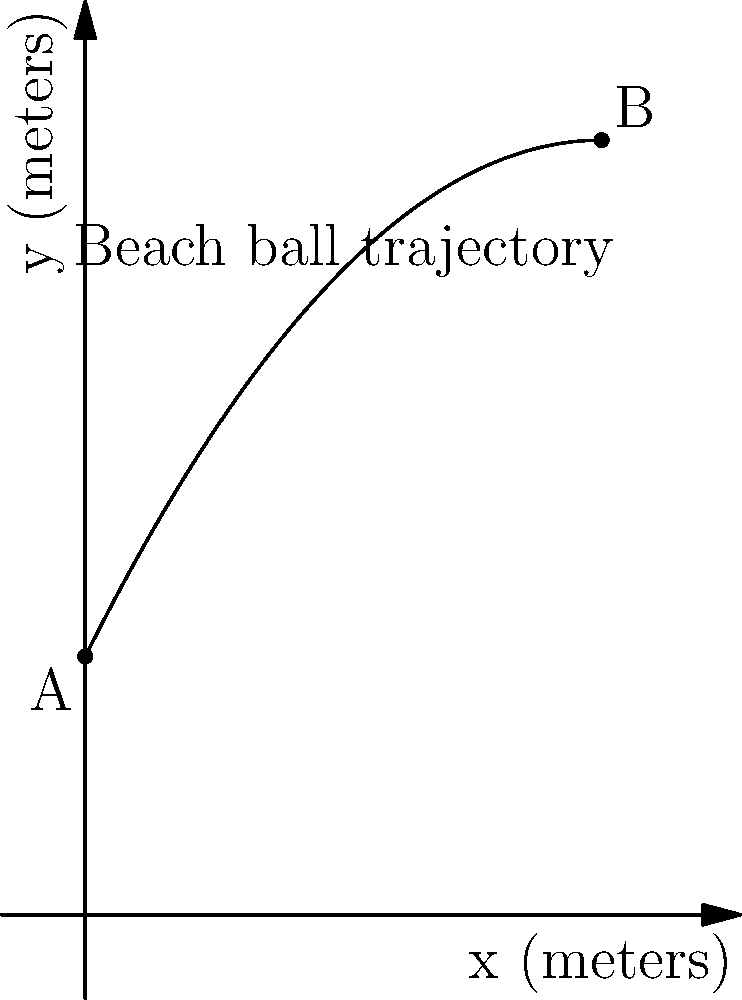At the Coachella Music Festival in Los Angeles, a No Doubt fan throws a beach ball from point A $(0,5)$ to point B $(10,15)$. The trajectory of the beach ball follows a parabolic path described by the function $f(x) = -0.1x^2 + 2x + 5$, where $x$ and $y$ are measured in meters. What is the maximum height reached by the beach ball during its flight? To find the maximum height of the beach ball's trajectory, we need to follow these steps:

1) The parabola's axis of symmetry is where the maximum height occurs. We can find this using the formula $x = -\frac{b}{2a}$ for a quadratic function $f(x) = ax^2 + bx + c$.

2) In our case, $a = -0.1$ and $b = 2$. Let's substitute these values:

   $x = -\frac{2}{2(-0.1)} = -\frac{2}{-0.2} = 10$

3) The x-coordinate of the highest point is 10 meters.

4) To find the y-coordinate (the maximum height), we substitute x = 10 into our original function:

   $f(10) = -0.1(10)^2 + 2(10) + 5$
   $= -0.1(100) + 20 + 5$
   $= -10 + 20 + 5$
   $= 15$

5) Therefore, the maximum height is 15 meters.

This result matches with point B $(10,15)$, which is indeed the highest point on the parabola.
Answer: 15 meters 